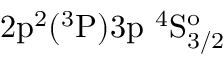<formula> <loc_0><loc_0><loc_500><loc_500>2 p ^ { 2 } ( ^ { 3 } P ) 3 p ^ { 4 } S _ { 3 / 2 } ^ { o }</formula> 